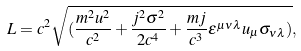<formula> <loc_0><loc_0><loc_500><loc_500>L = c ^ { 2 } \sqrt { ( { \frac { m ^ { 2 } u ^ { 2 } } { c ^ { 2 } } } + { \frac { j ^ { 2 } \sigma ^ { 2 } } { 2 c ^ { 4 } } } + { \frac { m j } { c ^ { 3 } } } \epsilon ^ { \mu \nu \lambda } u _ { \mu } \sigma _ { \nu \lambda } ) } ,</formula> 